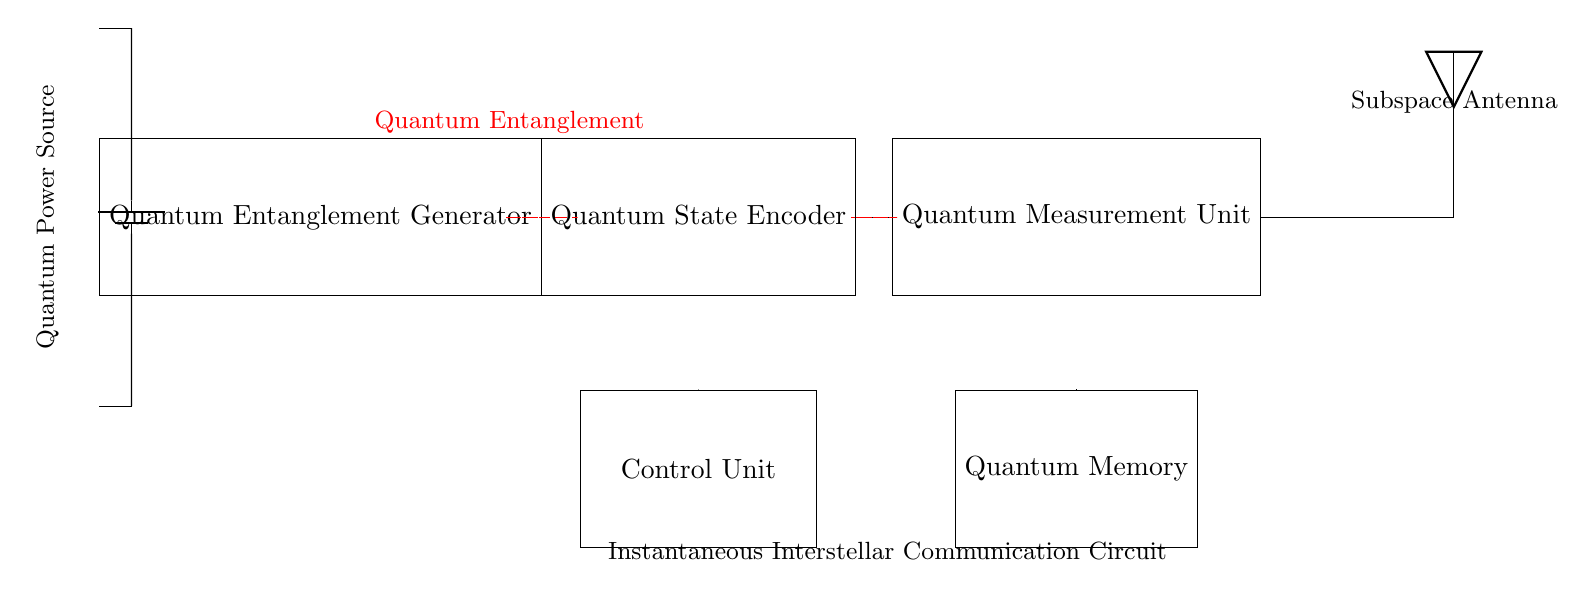What is the power source type in this circuit? The power source is a battery, indicated as a symbol with positive and negative terminals in the circuit diagram.
Answer: Battery What does the red dashed line represent in the circuit? The red dashed line denotes quantum entanglement connections between components. It shows how quantum states are shared instantaneously through the circuit.
Answer: Quantum entanglement Which component connects the Quantum Entanglement Generator and the Quantum State Encoder? The direct line connecting these two components indicates a connection and flow of information between the Quantum Entanglement Generator and the Quantum State Encoder.
Answer: Quantum State Encoder How many main components are there in this circuit? The main components are the Quantum Entanglement Generator, Quantum State Encoder, Quantum Measurement Unit, and Control Unit, making a total of five significant components.
Answer: Five What is the function of the Quantum Measurement Unit? The Quantum Measurement Unit processes the quantum states encoded earlier in the circuit and prepares them for transmission, which is crucial for ensuring the integrity of the communicated information.
Answer: Processing Which component’s role is to manage the overall function of the device? The Control Unit orchestrates the operations of other components, determining when and how data is processed and transmitted, thus managing the entire circuit's functionality.
Answer: Control Unit 